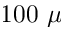Convert formula to latex. <formula><loc_0><loc_0><loc_500><loc_500>1 0 0 \mu</formula> 